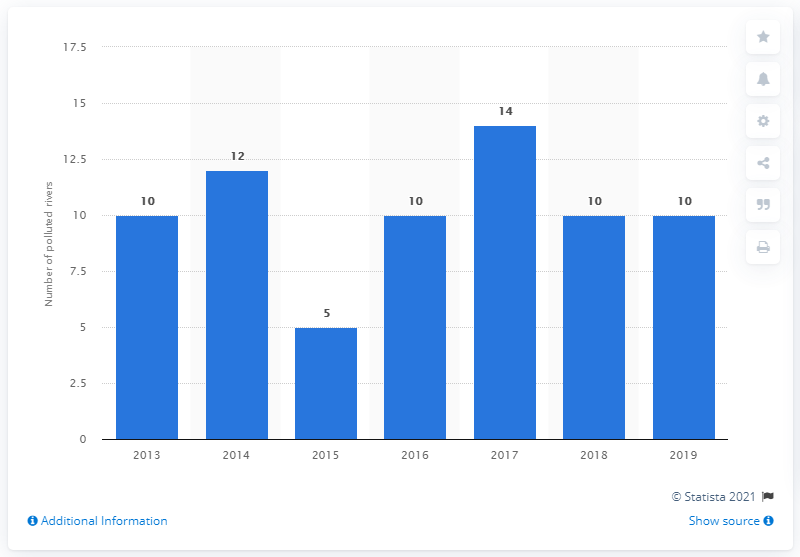Mention a couple of crucial points in this snapshot. There were five polluted rivers in Malaysia in 2019. In 2015, Malaysia had the fewest polluted rivers among all years. 